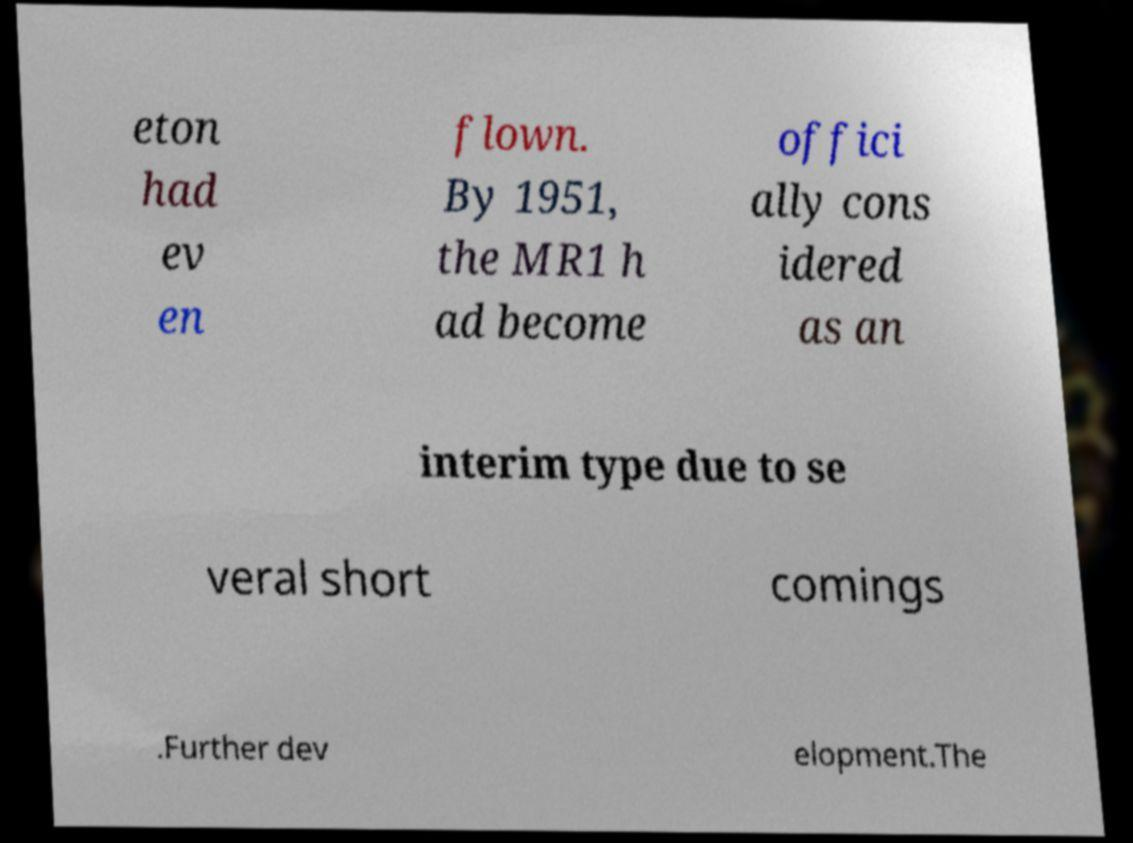What messages or text are displayed in this image? I need them in a readable, typed format. eton had ev en flown. By 1951, the MR1 h ad become offici ally cons idered as an interim type due to se veral short comings .Further dev elopment.The 